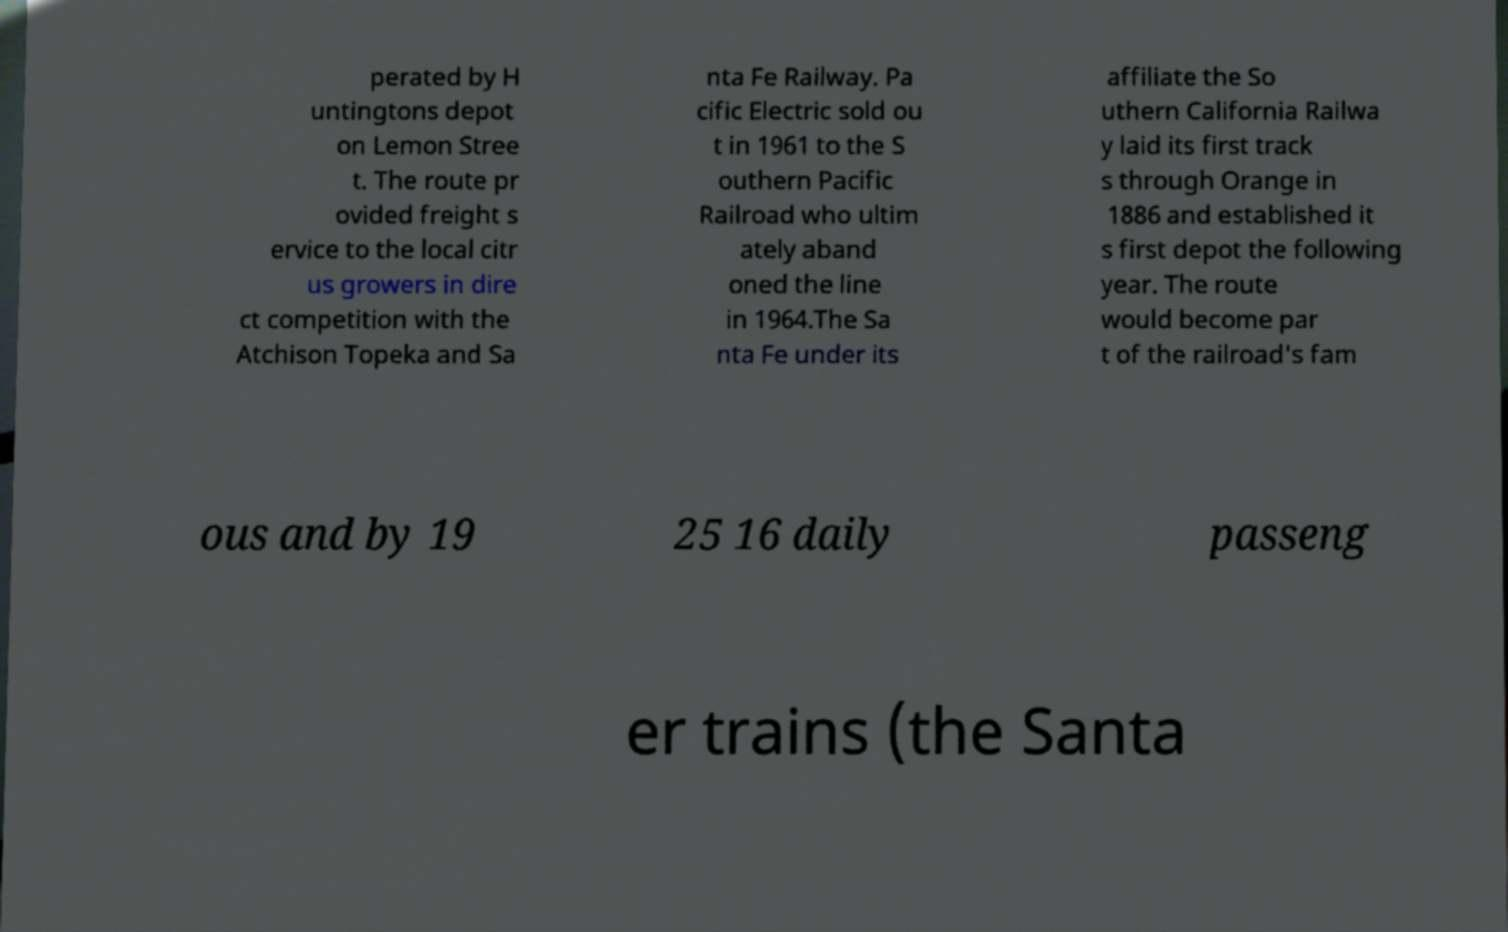Could you assist in decoding the text presented in this image and type it out clearly? perated by H untingtons depot on Lemon Stree t. The route pr ovided freight s ervice to the local citr us growers in dire ct competition with the Atchison Topeka and Sa nta Fe Railway. Pa cific Electric sold ou t in 1961 to the S outhern Pacific Railroad who ultim ately aband oned the line in 1964.The Sa nta Fe under its affiliate the So uthern California Railwa y laid its first track s through Orange in 1886 and established it s first depot the following year. The route would become par t of the railroad's fam ous and by 19 25 16 daily passeng er trains (the Santa 